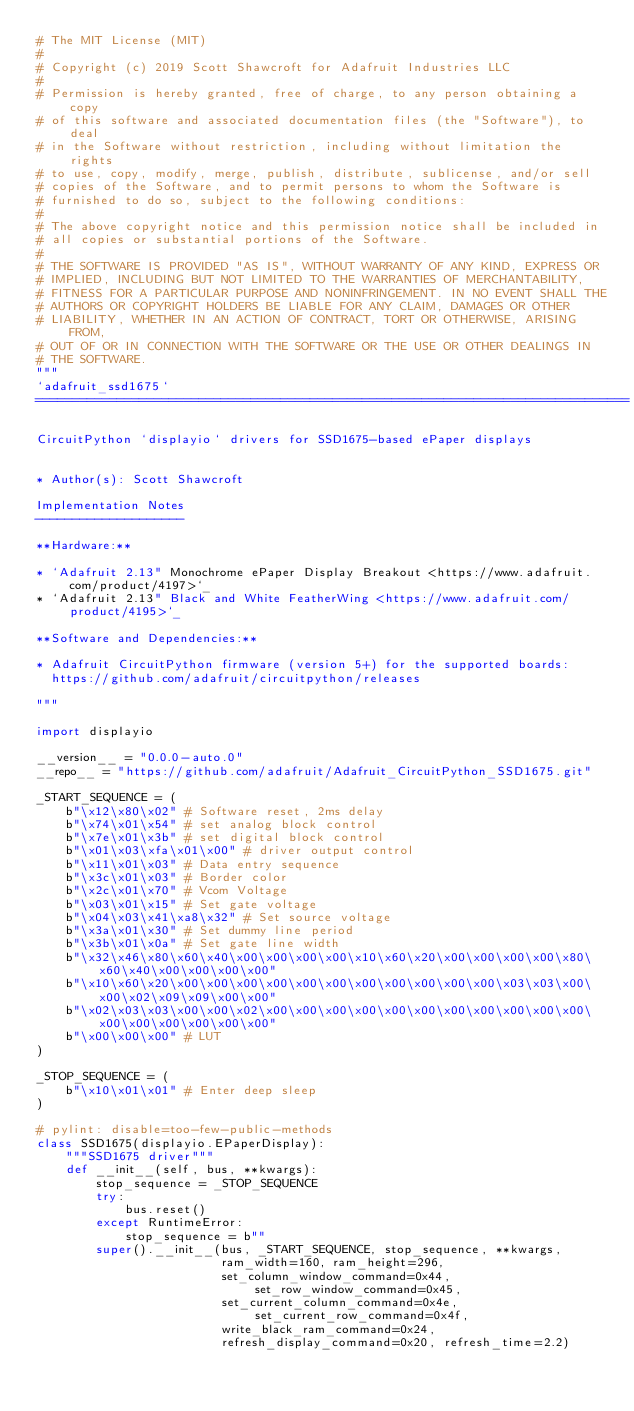<code> <loc_0><loc_0><loc_500><loc_500><_Python_># The MIT License (MIT)
#
# Copyright (c) 2019 Scott Shawcroft for Adafruit Industries LLC
#
# Permission is hereby granted, free of charge, to any person obtaining a copy
# of this software and associated documentation files (the "Software"), to deal
# in the Software without restriction, including without limitation the rights
# to use, copy, modify, merge, publish, distribute, sublicense, and/or sell
# copies of the Software, and to permit persons to whom the Software is
# furnished to do so, subject to the following conditions:
#
# The above copyright notice and this permission notice shall be included in
# all copies or substantial portions of the Software.
#
# THE SOFTWARE IS PROVIDED "AS IS", WITHOUT WARRANTY OF ANY KIND, EXPRESS OR
# IMPLIED, INCLUDING BUT NOT LIMITED TO THE WARRANTIES OF MERCHANTABILITY,
# FITNESS FOR A PARTICULAR PURPOSE AND NONINFRINGEMENT. IN NO EVENT SHALL THE
# AUTHORS OR COPYRIGHT HOLDERS BE LIABLE FOR ANY CLAIM, DAMAGES OR OTHER
# LIABILITY, WHETHER IN AN ACTION OF CONTRACT, TORT OR OTHERWISE, ARISING FROM,
# OUT OF OR IN CONNECTION WITH THE SOFTWARE OR THE USE OR OTHER DEALINGS IN
# THE SOFTWARE.
"""
`adafruit_ssd1675`
================================================================================

CircuitPython `displayio` drivers for SSD1675-based ePaper displays


* Author(s): Scott Shawcroft

Implementation Notes
--------------------

**Hardware:**

* `Adafruit 2.13" Monochrome ePaper Display Breakout <https://www.adafruit.com/product/4197>`_
* `Adafruit 2.13" Black and White FeatherWing <https://www.adafruit.com/product/4195>`_

**Software and Dependencies:**

* Adafruit CircuitPython firmware (version 5+) for the supported boards:
  https://github.com/adafruit/circuitpython/releases

"""

import displayio

__version__ = "0.0.0-auto.0"
__repo__ = "https://github.com/adafruit/Adafruit_CircuitPython_SSD1675.git"

_START_SEQUENCE = (
    b"\x12\x80\x02" # Software reset, 2ms delay
    b"\x74\x01\x54" # set analog block control
    b"\x7e\x01\x3b" # set digital block control
    b"\x01\x03\xfa\x01\x00" # driver output control
    b"\x11\x01\x03" # Data entry sequence
    b"\x3c\x01\x03" # Border color
    b"\x2c\x01\x70" # Vcom Voltage
    b"\x03\x01\x15" # Set gate voltage
    b"\x04\x03\x41\xa8\x32" # Set source voltage
    b"\x3a\x01\x30" # Set dummy line period
    b"\x3b\x01\x0a" # Set gate line width
    b"\x32\x46\x80\x60\x40\x00\x00\x00\x00\x10\x60\x20\x00\x00\x00\x00\x80\x60\x40\x00\x00\x00\x00"
    b"\x10\x60\x20\x00\x00\x00\x00\x00\x00\x00\x00\x00\x00\x00\x03\x03\x00\x00\x02\x09\x09\x00\x00"
    b"\x02\x03\x03\x00\x00\x02\x00\x00\x00\x00\x00\x00\x00\x00\x00\x00\x00\x00\x00\x00\x00\x00\x00"
    b"\x00\x00\x00" # LUT
)

_STOP_SEQUENCE = (
    b"\x10\x01\x01" # Enter deep sleep
)

# pylint: disable=too-few-public-methods
class SSD1675(displayio.EPaperDisplay):
    """SSD1675 driver"""
    def __init__(self, bus, **kwargs):
        stop_sequence = _STOP_SEQUENCE
        try:
            bus.reset()
        except RuntimeError:
            stop_sequence = b""
        super().__init__(bus, _START_SEQUENCE, stop_sequence, **kwargs,
                         ram_width=160, ram_height=296,
                         set_column_window_command=0x44, set_row_window_command=0x45,
                         set_current_column_command=0x4e, set_current_row_command=0x4f,
                         write_black_ram_command=0x24,
                         refresh_display_command=0x20, refresh_time=2.2)
</code> 